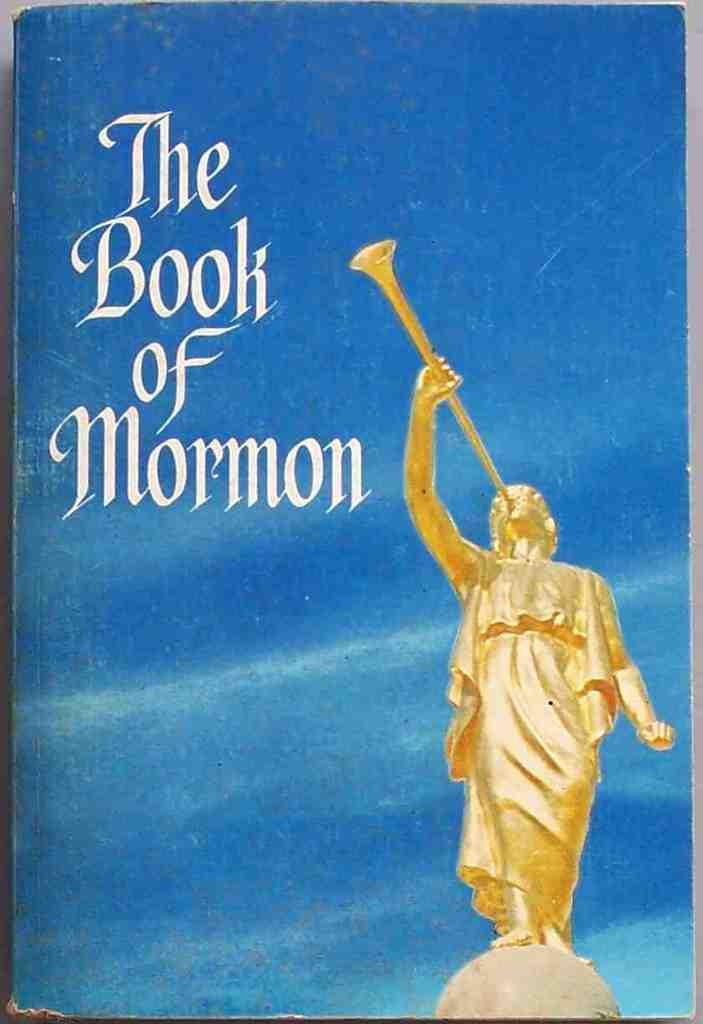<image>
Relay a brief, clear account of the picture shown. A book entitled "The Book of Mormon" has a blue cover. 